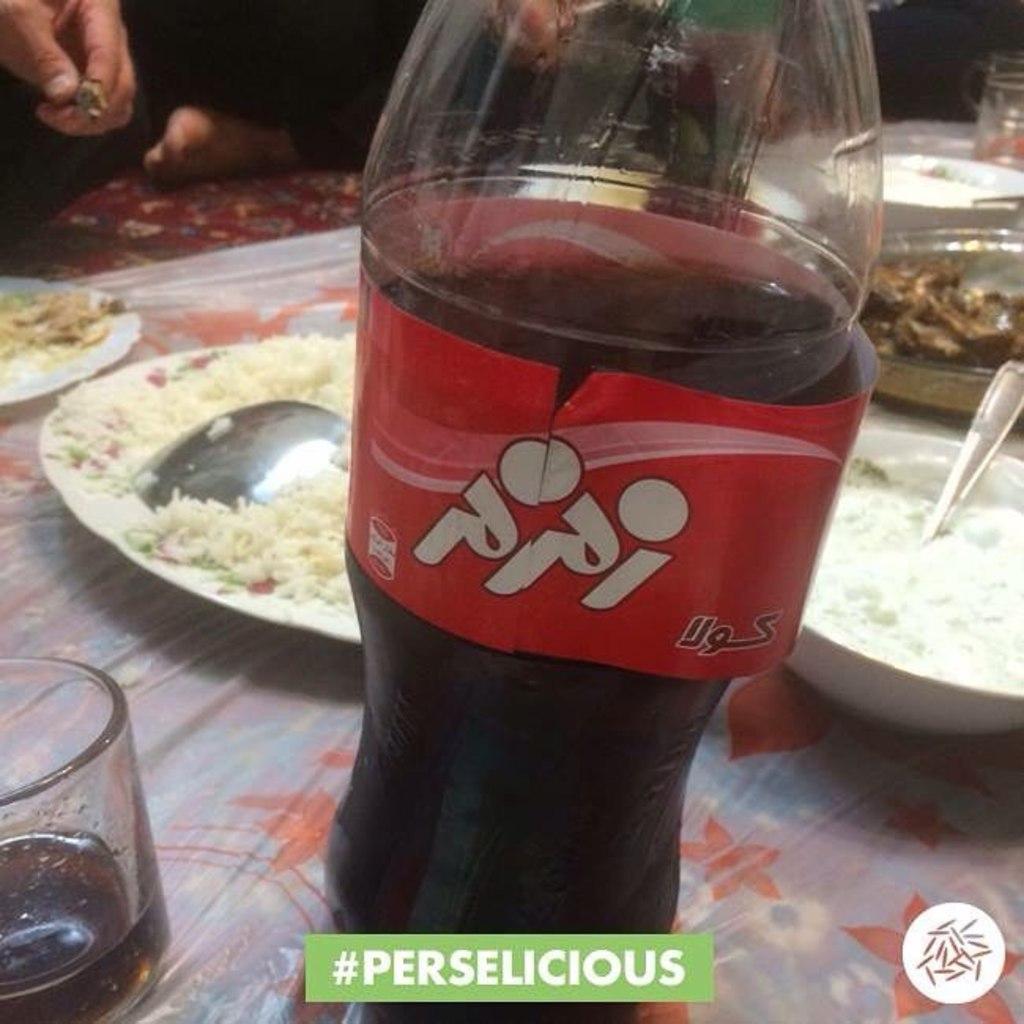In one or two sentences, can you explain what this image depicts? In this picture we can see a bottle, glass, plates, spoon, bowls, and some food, and also we can see a human. 